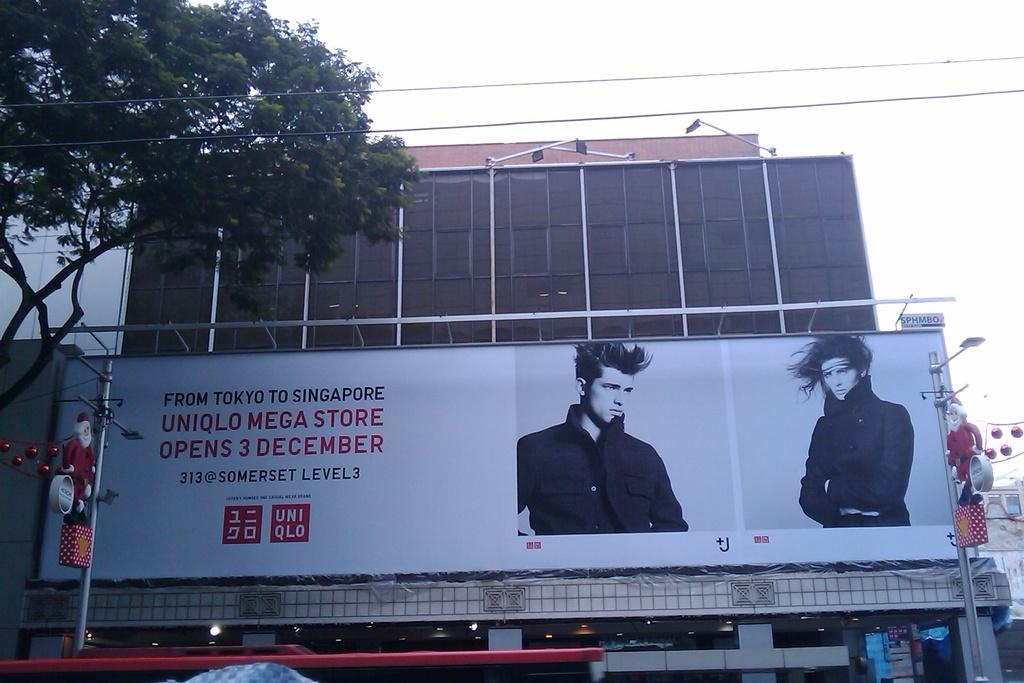<image>
Provide a brief description of the given image. an advertisement with Tokyo to Singapore on it 